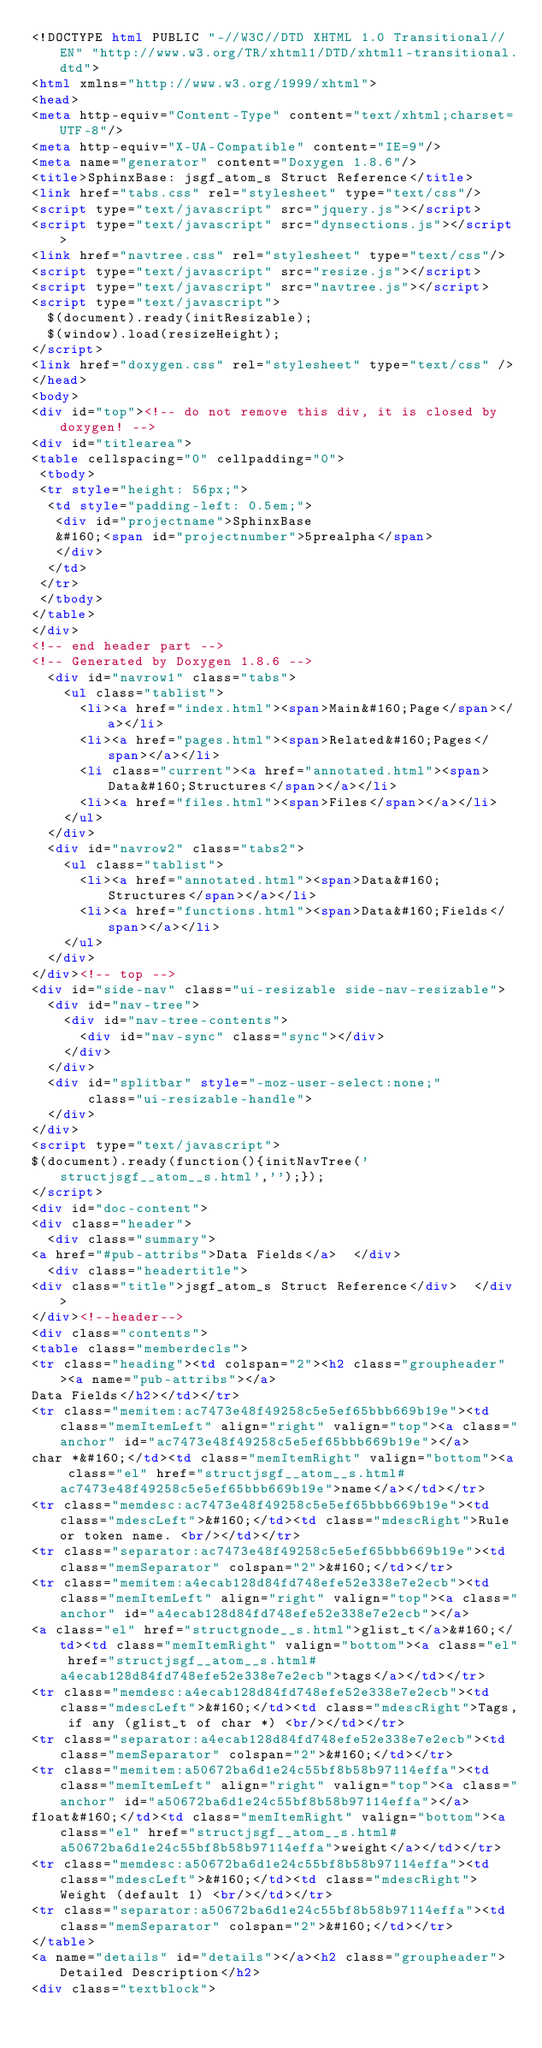<code> <loc_0><loc_0><loc_500><loc_500><_HTML_><!DOCTYPE html PUBLIC "-//W3C//DTD XHTML 1.0 Transitional//EN" "http://www.w3.org/TR/xhtml1/DTD/xhtml1-transitional.dtd">
<html xmlns="http://www.w3.org/1999/xhtml">
<head>
<meta http-equiv="Content-Type" content="text/xhtml;charset=UTF-8"/>
<meta http-equiv="X-UA-Compatible" content="IE=9"/>
<meta name="generator" content="Doxygen 1.8.6"/>
<title>SphinxBase: jsgf_atom_s Struct Reference</title>
<link href="tabs.css" rel="stylesheet" type="text/css"/>
<script type="text/javascript" src="jquery.js"></script>
<script type="text/javascript" src="dynsections.js"></script>
<link href="navtree.css" rel="stylesheet" type="text/css"/>
<script type="text/javascript" src="resize.js"></script>
<script type="text/javascript" src="navtree.js"></script>
<script type="text/javascript">
  $(document).ready(initResizable);
  $(window).load(resizeHeight);
</script>
<link href="doxygen.css" rel="stylesheet" type="text/css" />
</head>
<body>
<div id="top"><!-- do not remove this div, it is closed by doxygen! -->
<div id="titlearea">
<table cellspacing="0" cellpadding="0">
 <tbody>
 <tr style="height: 56px;">
  <td style="padding-left: 0.5em;">
   <div id="projectname">SphinxBase
   &#160;<span id="projectnumber">5prealpha</span>
   </div>
  </td>
 </tr>
 </tbody>
</table>
</div>
<!-- end header part -->
<!-- Generated by Doxygen 1.8.6 -->
  <div id="navrow1" class="tabs">
    <ul class="tablist">
      <li><a href="index.html"><span>Main&#160;Page</span></a></li>
      <li><a href="pages.html"><span>Related&#160;Pages</span></a></li>
      <li class="current"><a href="annotated.html"><span>Data&#160;Structures</span></a></li>
      <li><a href="files.html"><span>Files</span></a></li>
    </ul>
  </div>
  <div id="navrow2" class="tabs2">
    <ul class="tablist">
      <li><a href="annotated.html"><span>Data&#160;Structures</span></a></li>
      <li><a href="functions.html"><span>Data&#160;Fields</span></a></li>
    </ul>
  </div>
</div><!-- top -->
<div id="side-nav" class="ui-resizable side-nav-resizable">
  <div id="nav-tree">
    <div id="nav-tree-contents">
      <div id="nav-sync" class="sync"></div>
    </div>
  </div>
  <div id="splitbar" style="-moz-user-select:none;" 
       class="ui-resizable-handle">
  </div>
</div>
<script type="text/javascript">
$(document).ready(function(){initNavTree('structjsgf__atom__s.html','');});
</script>
<div id="doc-content">
<div class="header">
  <div class="summary">
<a href="#pub-attribs">Data Fields</a>  </div>
  <div class="headertitle">
<div class="title">jsgf_atom_s Struct Reference</div>  </div>
</div><!--header-->
<div class="contents">
<table class="memberdecls">
<tr class="heading"><td colspan="2"><h2 class="groupheader"><a name="pub-attribs"></a>
Data Fields</h2></td></tr>
<tr class="memitem:ac7473e48f49258c5e5ef65bbb669b19e"><td class="memItemLeft" align="right" valign="top"><a class="anchor" id="ac7473e48f49258c5e5ef65bbb669b19e"></a>
char *&#160;</td><td class="memItemRight" valign="bottom"><a class="el" href="structjsgf__atom__s.html#ac7473e48f49258c5e5ef65bbb669b19e">name</a></td></tr>
<tr class="memdesc:ac7473e48f49258c5e5ef65bbb669b19e"><td class="mdescLeft">&#160;</td><td class="mdescRight">Rule or token name. <br/></td></tr>
<tr class="separator:ac7473e48f49258c5e5ef65bbb669b19e"><td class="memSeparator" colspan="2">&#160;</td></tr>
<tr class="memitem:a4ecab128d84fd748efe52e338e7e2ecb"><td class="memItemLeft" align="right" valign="top"><a class="anchor" id="a4ecab128d84fd748efe52e338e7e2ecb"></a>
<a class="el" href="structgnode__s.html">glist_t</a>&#160;</td><td class="memItemRight" valign="bottom"><a class="el" href="structjsgf__atom__s.html#a4ecab128d84fd748efe52e338e7e2ecb">tags</a></td></tr>
<tr class="memdesc:a4ecab128d84fd748efe52e338e7e2ecb"><td class="mdescLeft">&#160;</td><td class="mdescRight">Tags, if any (glist_t of char *) <br/></td></tr>
<tr class="separator:a4ecab128d84fd748efe52e338e7e2ecb"><td class="memSeparator" colspan="2">&#160;</td></tr>
<tr class="memitem:a50672ba6d1e24c55bf8b58b97114effa"><td class="memItemLeft" align="right" valign="top"><a class="anchor" id="a50672ba6d1e24c55bf8b58b97114effa"></a>
float&#160;</td><td class="memItemRight" valign="bottom"><a class="el" href="structjsgf__atom__s.html#a50672ba6d1e24c55bf8b58b97114effa">weight</a></td></tr>
<tr class="memdesc:a50672ba6d1e24c55bf8b58b97114effa"><td class="mdescLeft">&#160;</td><td class="mdescRight">Weight (default 1) <br/></td></tr>
<tr class="separator:a50672ba6d1e24c55bf8b58b97114effa"><td class="memSeparator" colspan="2">&#160;</td></tr>
</table>
<a name="details" id="details"></a><h2 class="groupheader">Detailed Description</h2>
<div class="textblock"></code> 